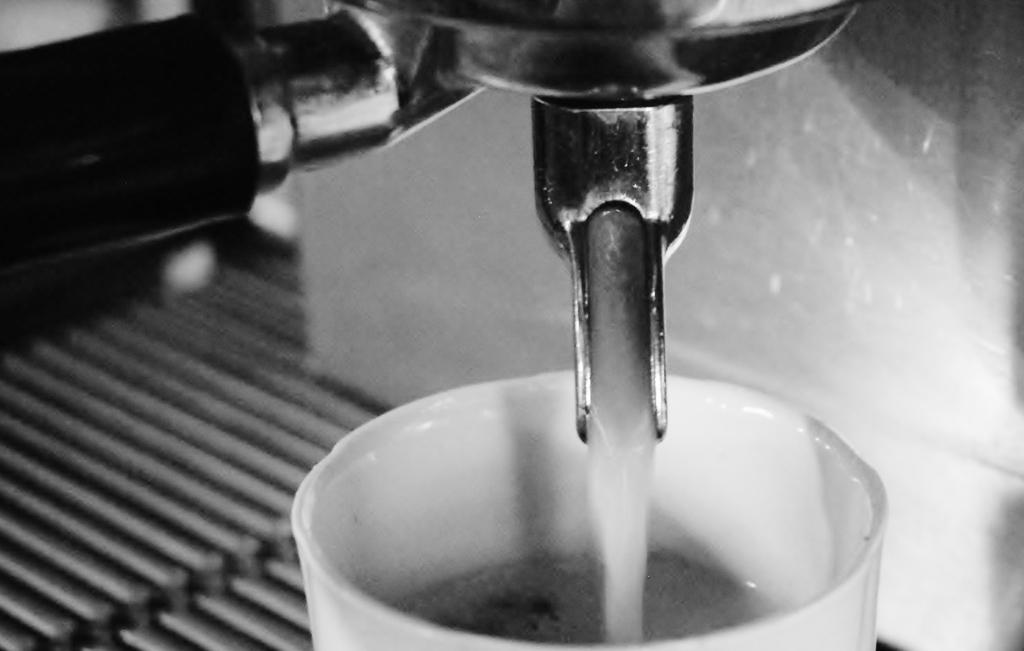What type of machine is visible in the image? There is a fluid machine in the image. What is placed near the machine? There is a cup with liquid in the image. What is the material of the machine's surface? The surface of the machine appears to be metallic. What can be seen on the right side of the image? There is a wall on the right side of the image. Can you see any quicksand near the machine in the image? There is no quicksand present in the image. What type of apple is being used to operate the machine in the image? There is no apple present in the image, and the machine does not require an apple to operate. 